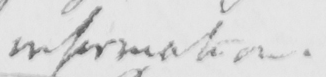Can you tell me what this handwritten text says? -information . 